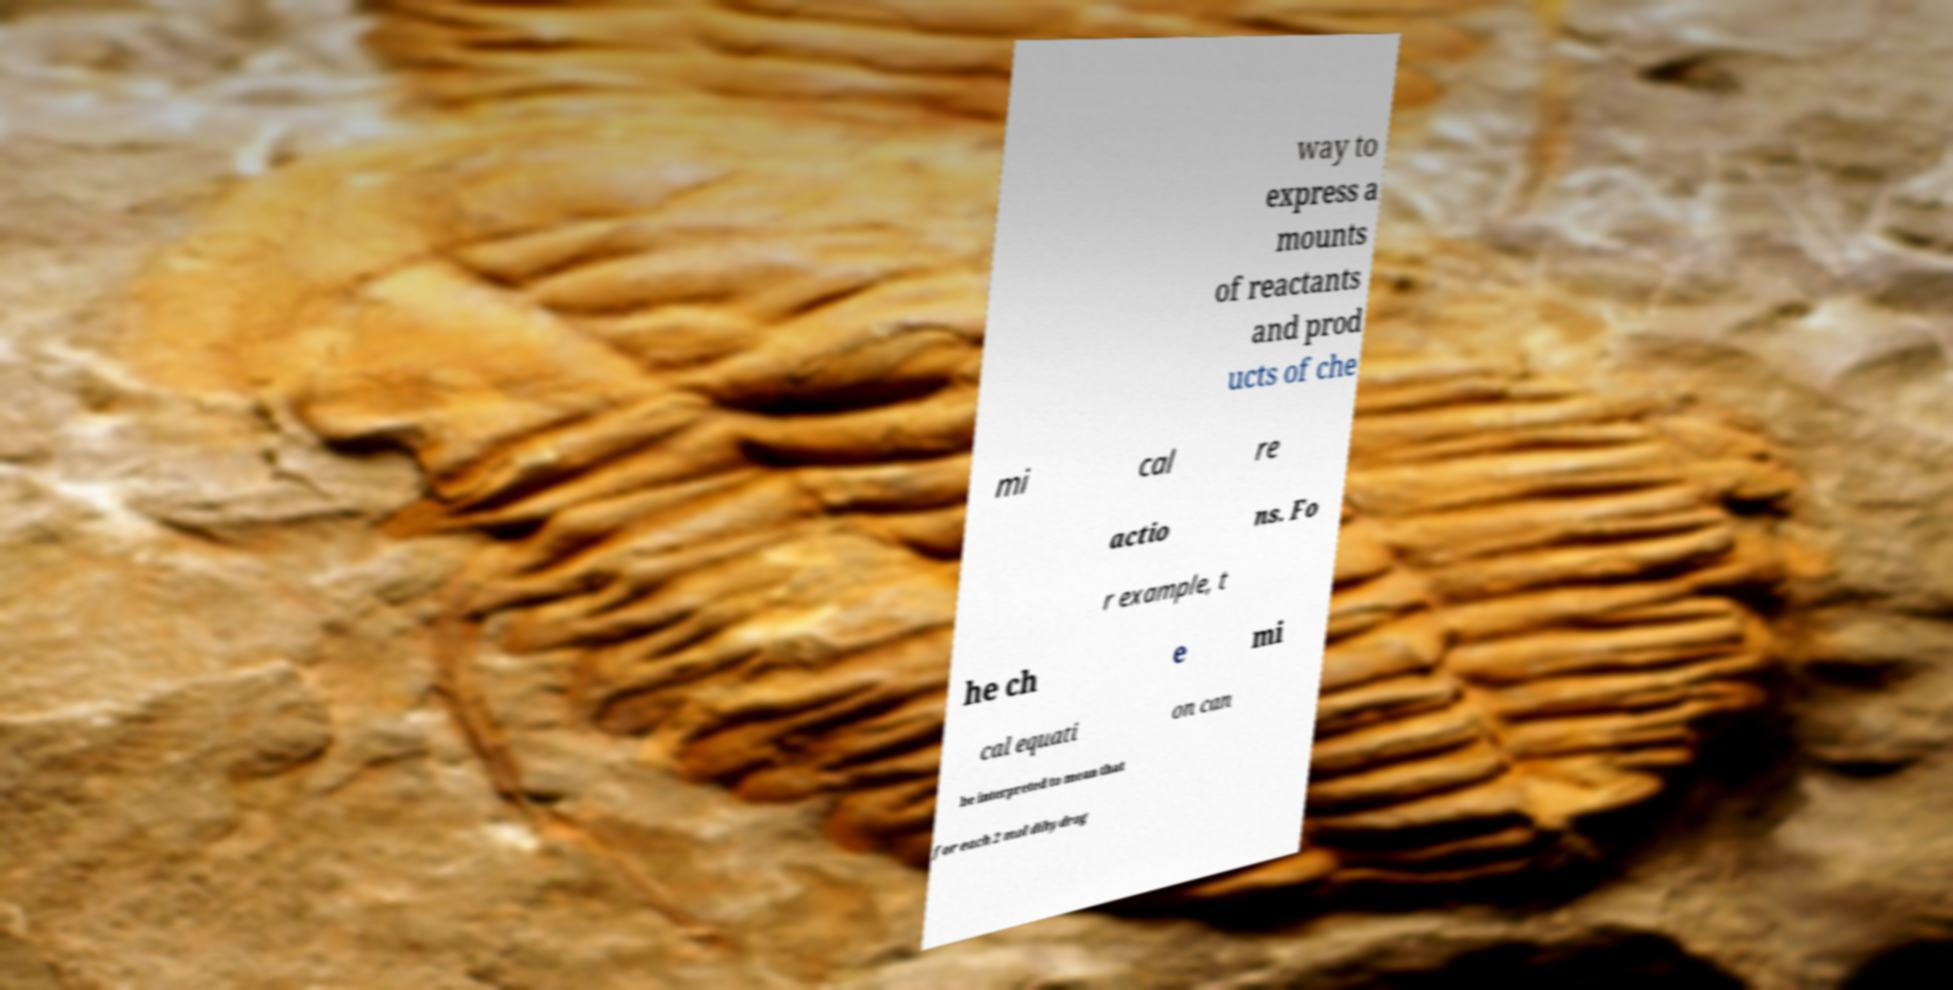I need the written content from this picture converted into text. Can you do that? way to express a mounts of reactants and prod ucts of che mi cal re actio ns. Fo r example, t he ch e mi cal equati on can be interpreted to mean that for each 2 mol dihydrog 